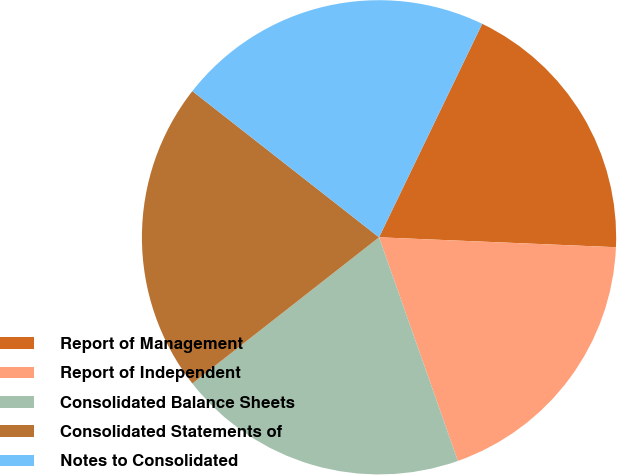Convert chart to OTSL. <chart><loc_0><loc_0><loc_500><loc_500><pie_chart><fcel>Report of Management<fcel>Report of Independent<fcel>Consolidated Balance Sheets<fcel>Consolidated Statements of<fcel>Notes to Consolidated<nl><fcel>18.5%<fcel>18.94%<fcel>19.82%<fcel>21.15%<fcel>21.59%<nl></chart> 